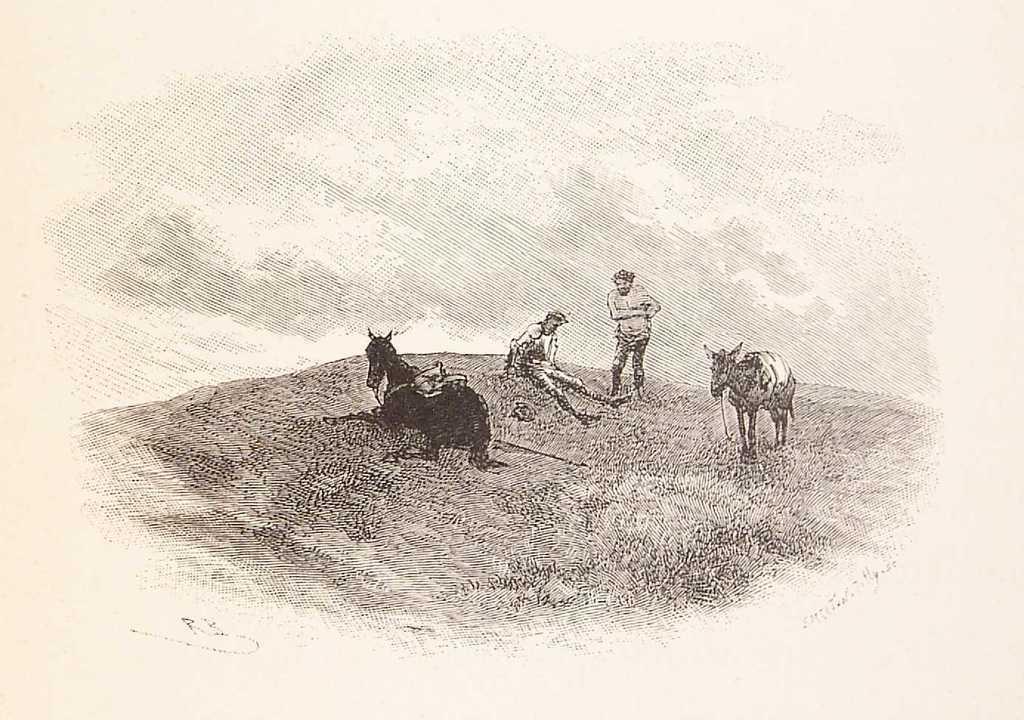Could you give a brief overview of what you see in this image? In this image I can see two animals and I can also see two persons, and the image is in black and white. 